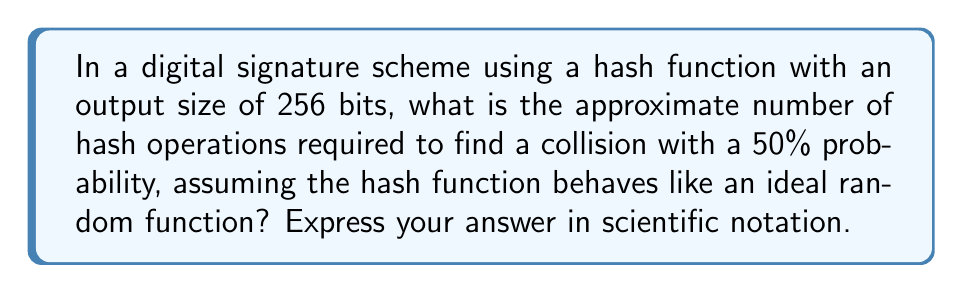Help me with this question. To solve this problem, we need to understand the birthday attack and its application to hash function collisions. Let's break it down step-by-step:

1) The birthday attack is based on the birthday paradox, which states that in a group of 23 people, there's about a 50% chance that two people share the same birthday.

2) For a hash function with an output size of $n$ bits, the number of possible hash values is $2^n$.

3) The probability of finding a collision after $k$ attempts is approximately:

   $P(collision) \approx 1 - e^{-k^2/(2 \cdot 2^n)}$

4) We want to find $k$ when $P(collision) = 0.5$ (50% probability):

   $0.5 \approx 1 - e^{-k^2/(2 \cdot 2^n)}$

5) Solving for $k$:

   $e^{-k^2/(2 \cdot 2^n)} \approx 0.5$
   $-k^2/(2 \cdot 2^n) \approx \ln(0.5)$
   $k^2 \approx -2 \cdot 2^n \cdot \ln(0.5)$
   $k \approx \sqrt{-2 \cdot 2^n \cdot \ln(0.5)}$

6) For a 256-bit hash function:

   $k \approx \sqrt{-2 \cdot 2^{256} \cdot \ln(0.5)}$
   $k \approx \sqrt{2^{257} \cdot 0.693}$
   $k \approx 1.18 \cdot 2^{128}$

7) Converting to scientific notation:

   $k \approx 1.18 \cdot 2^{128} \approx 3.98 \times 10^{38}$

Therefore, approximately $3.98 \times 10^{38}$ hash operations are required to find a collision with 50% probability.
Answer: $3.98 \times 10^{38}$ 